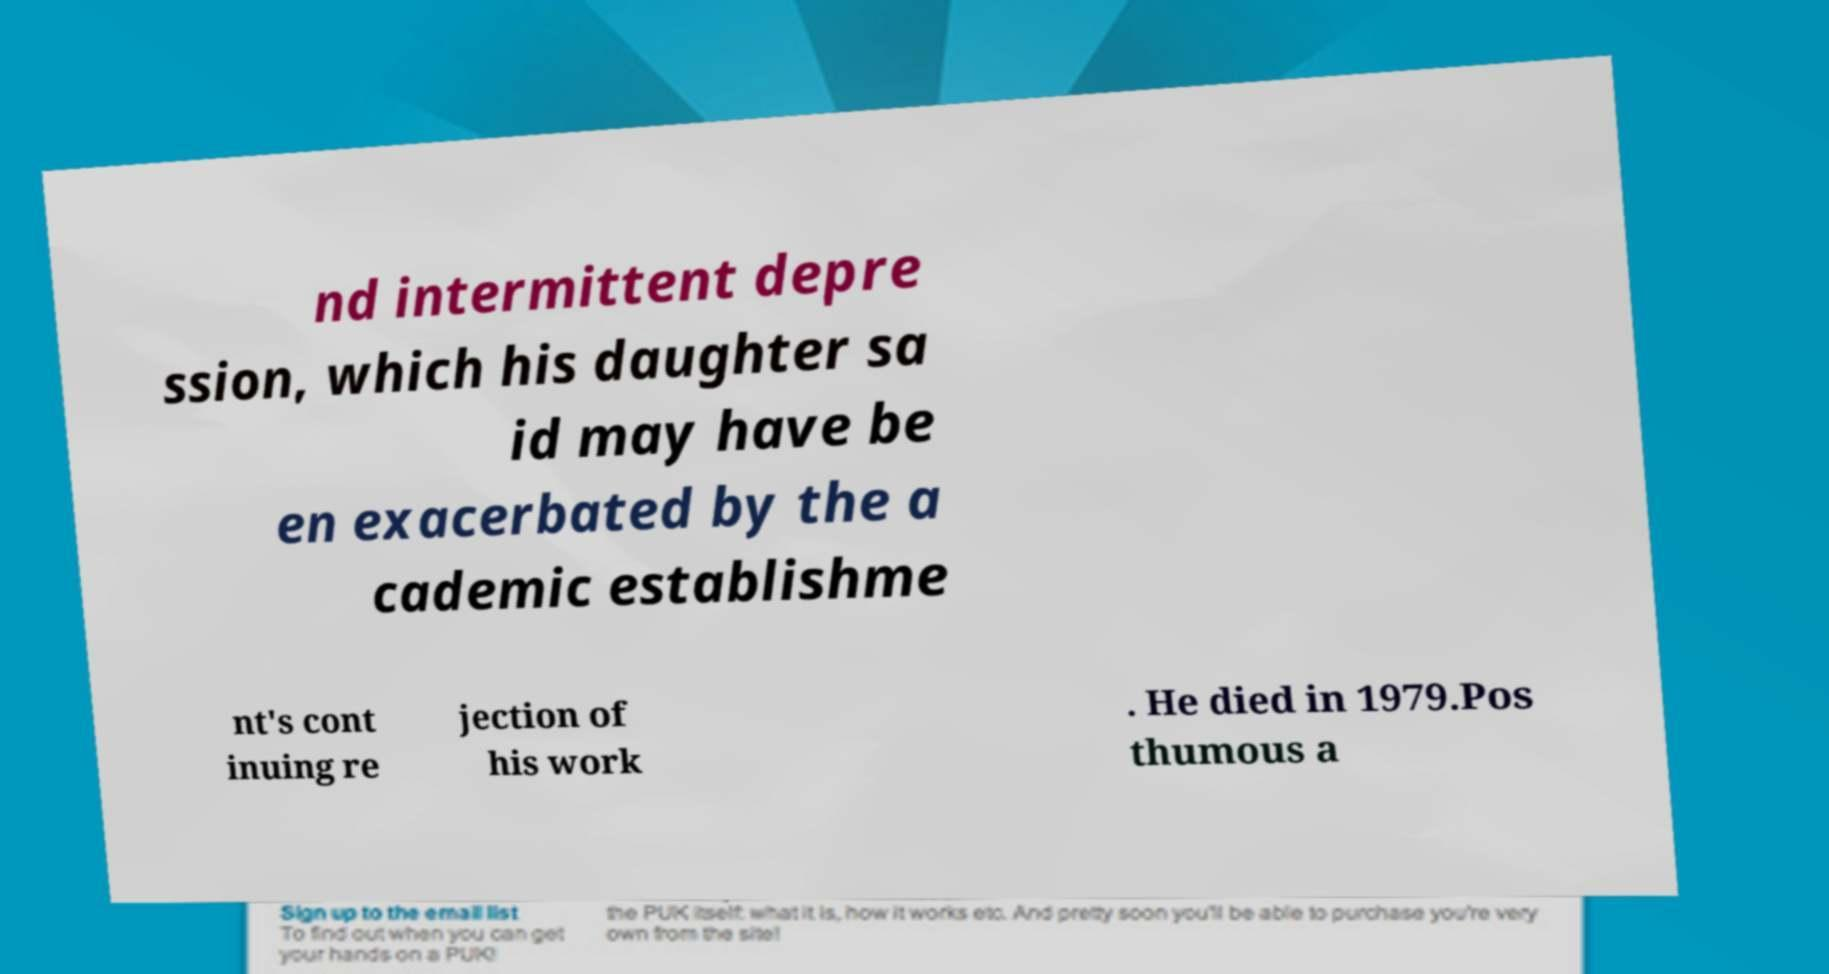Please identify and transcribe the text found in this image. nd intermittent depre ssion, which his daughter sa id may have be en exacerbated by the a cademic establishme nt's cont inuing re jection of his work . He died in 1979.Pos thumous a 